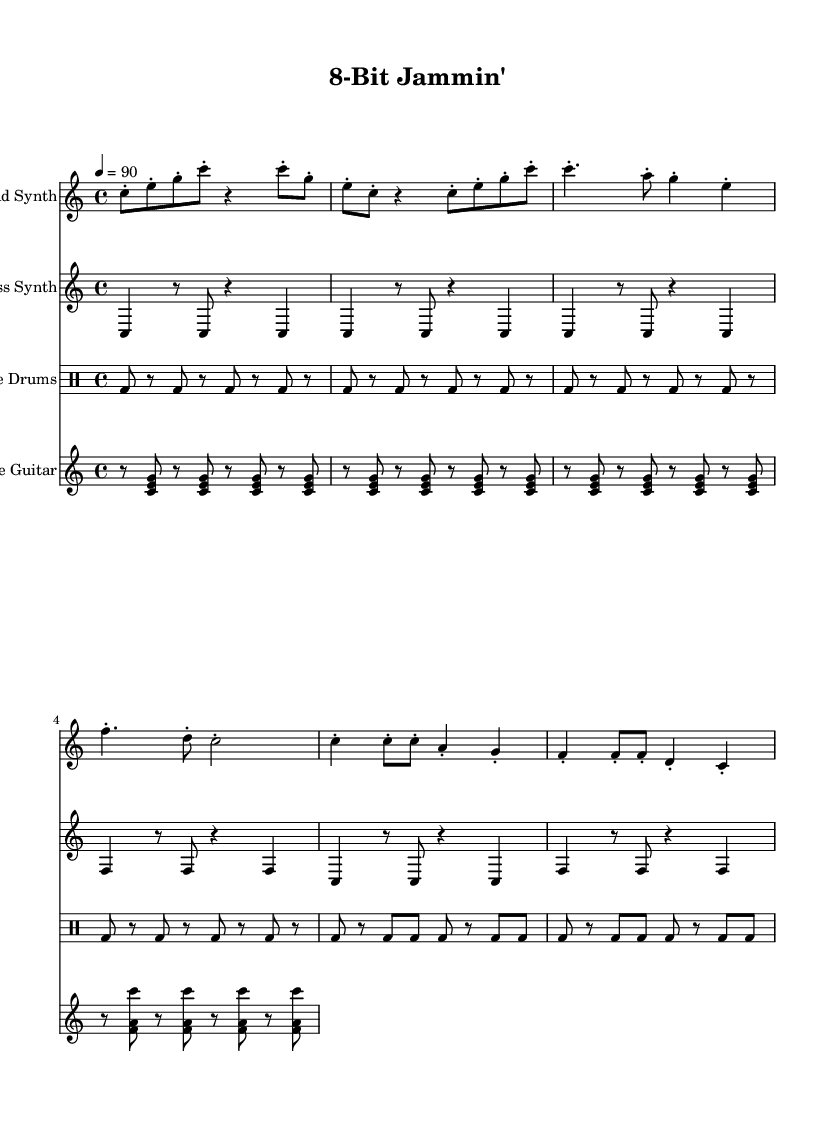What is the key signature of this music? The key signature is C major, which has no sharps or flats.
Answer: C major What is the time signature of this music? The time signature is indicated at the beginning as 4/4, meaning there are four beats in a measure.
Answer: 4/4 What is the tempo marking in this piece? The tempo marking is indicated as "4 = 90," meaning there should be 90 quarter notes played per minute.
Answer: 90 How many measures are in the lead synth part? The lead synth part contains a total of 8 measures, as indicated by the number of distinct sections before the end.
Answer: 8 What rhythmic style is used in the rhythm guitar part? The rhythm guitar part features a typical reggae off-beat accentuation, emphasizing the off-beats in the measure.
Answer: Off-beat accentuation What type of drum pattern is used in the chiptune drums? The chiptune drums use a steady bass drum pattern throughout, with consistent hits that create a driving rhythm.
Answer: Steady bass drum pattern Which instrument plays the melodic lead in this piece? The lead synth plays the melodic lead, as indicated by its name and the notes written in that staff.
Answer: Lead Synth 